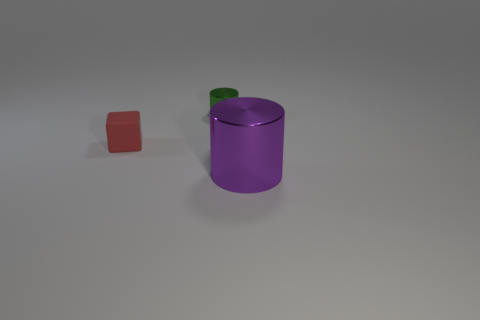Are there any cubes in front of the small shiny thing?
Your answer should be compact. Yes. What is the shape of the large purple object?
Give a very brief answer. Cylinder. What is the shape of the shiny object that is to the left of the cylinder on the right side of the shiny cylinder that is behind the purple metallic object?
Make the answer very short. Cylinder. How many other objects are there of the same shape as the purple object?
Your answer should be compact. 1. What material is the cylinder that is behind the metallic cylinder that is in front of the red block?
Give a very brief answer. Metal. Are there any other things that have the same size as the purple cylinder?
Keep it short and to the point. No. Do the red cube and the cylinder in front of the red rubber block have the same material?
Provide a succinct answer. No. The thing that is to the left of the large purple thing and in front of the green shiny object is made of what material?
Make the answer very short. Rubber. What is the color of the small thing that is to the left of the object that is behind the tiny red cube?
Keep it short and to the point. Red. What is the cylinder that is in front of the red thing made of?
Give a very brief answer. Metal. 